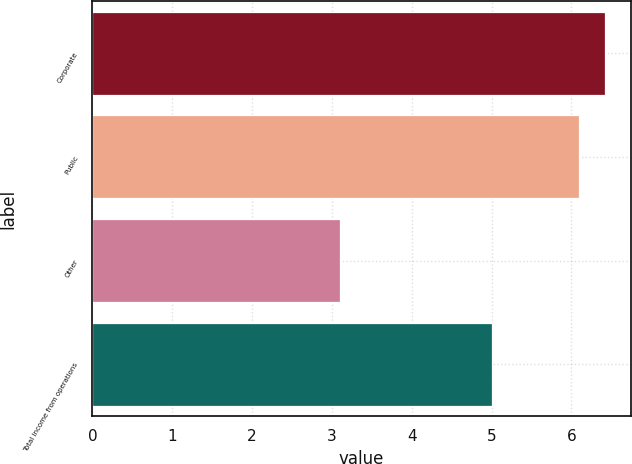Convert chart. <chart><loc_0><loc_0><loc_500><loc_500><bar_chart><fcel>Corporate<fcel>Public<fcel>Other<fcel>Total income from operations<nl><fcel>6.42<fcel>6.1<fcel>3.1<fcel>5<nl></chart> 